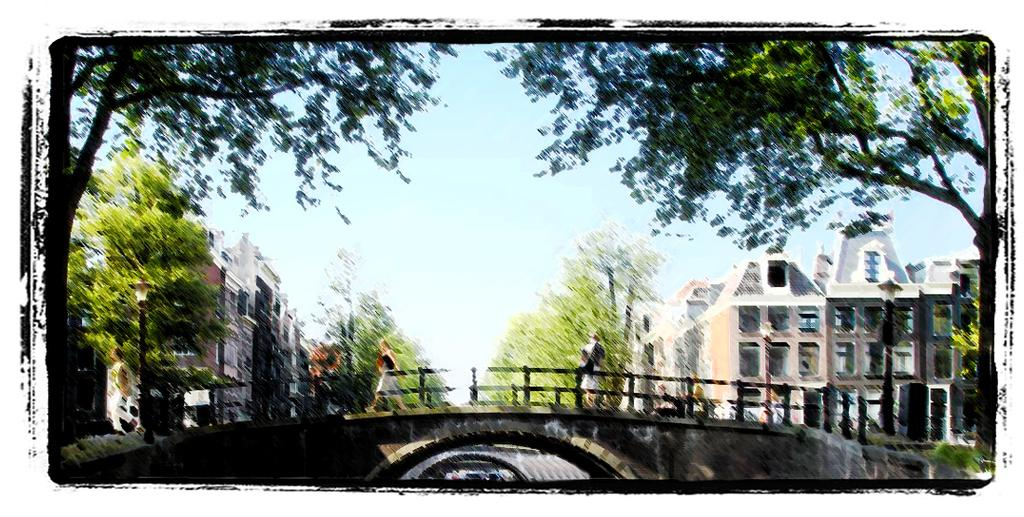What type of artwork is depicted in the image? The image is a painting. What structures can be seen in the painting? There are buildings and a bridge in the painting. What type of vegetation is present in the painting? There are trees in the painting. What is the color of the sky in the painting? The sky in the painting is blue. What are the people in the painting doing? The people in the painting are walking on a bridge. Where is the desk located in the painting? There is no desk present in the painting. What type of authority is depicted in the painting? The painting does not depict any specific authority figure. 